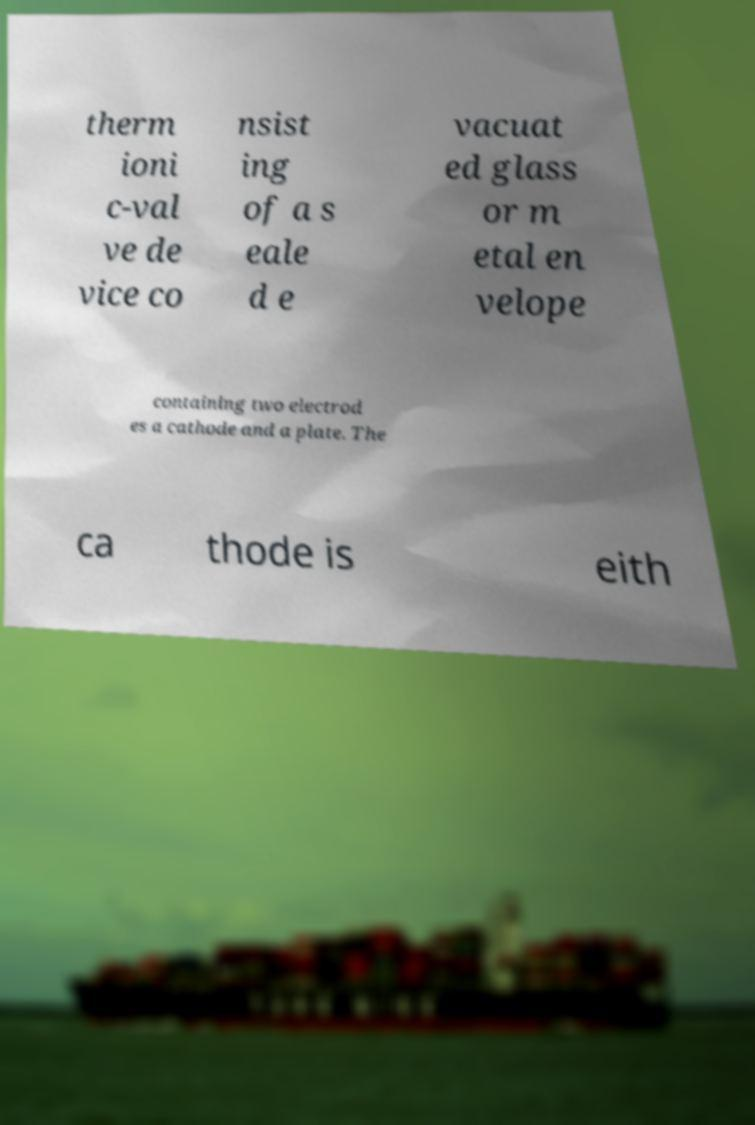Could you assist in decoding the text presented in this image and type it out clearly? therm ioni c-val ve de vice co nsist ing of a s eale d e vacuat ed glass or m etal en velope containing two electrod es a cathode and a plate. The ca thode is eith 